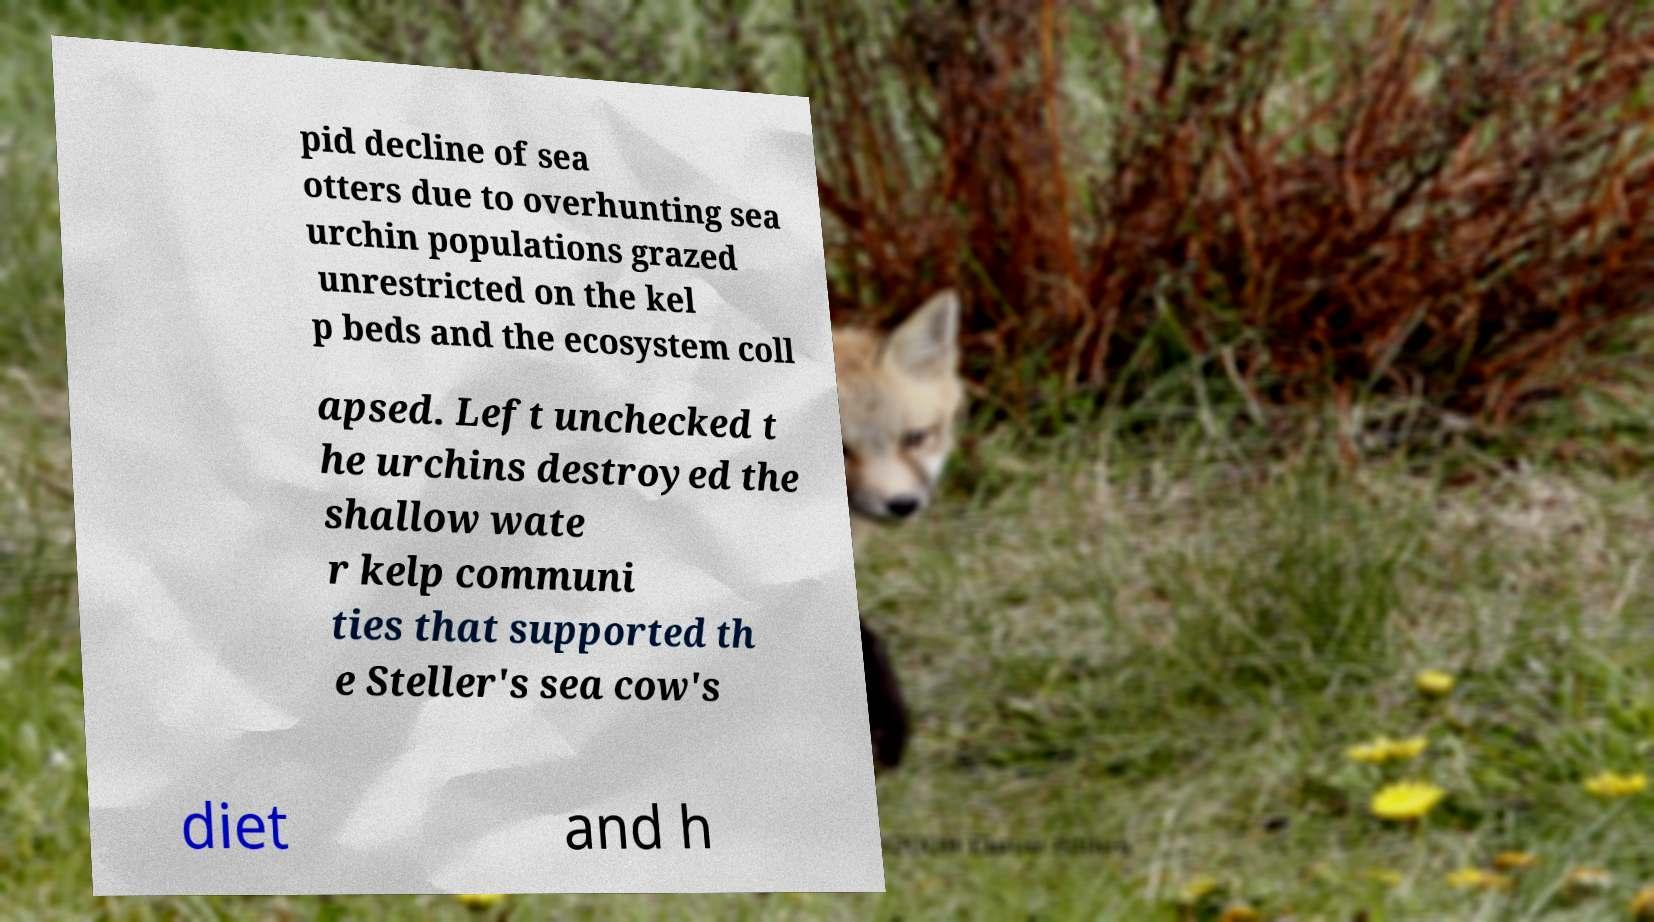Can you read and provide the text displayed in the image?This photo seems to have some interesting text. Can you extract and type it out for me? pid decline of sea otters due to overhunting sea urchin populations grazed unrestricted on the kel p beds and the ecosystem coll apsed. Left unchecked t he urchins destroyed the shallow wate r kelp communi ties that supported th e Steller's sea cow's diet and h 